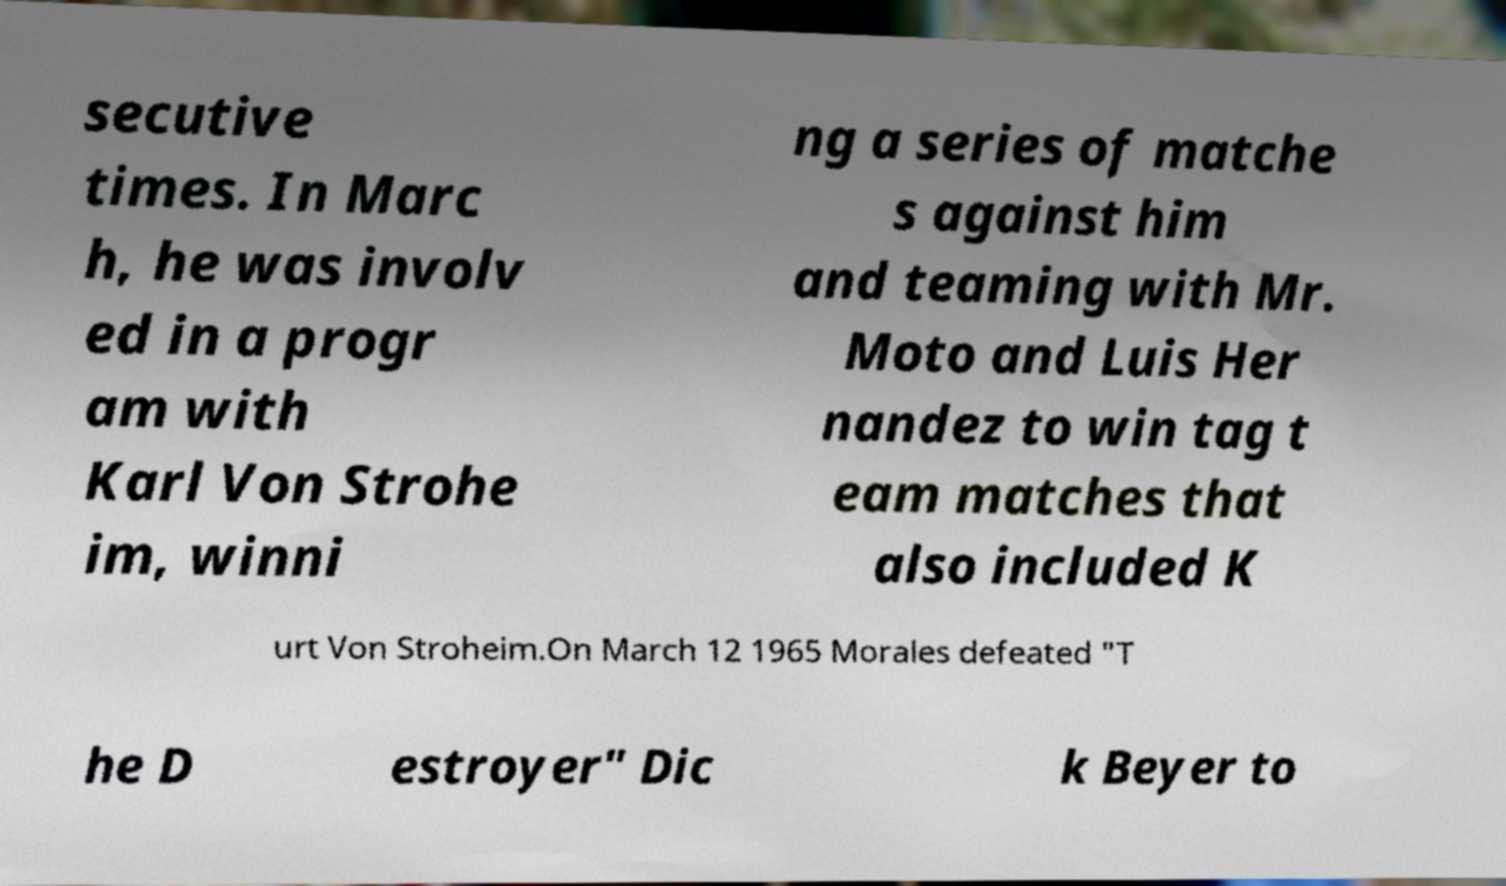Please identify and transcribe the text found in this image. secutive times. In Marc h, he was involv ed in a progr am with Karl Von Strohe im, winni ng a series of matche s against him and teaming with Mr. Moto and Luis Her nandez to win tag t eam matches that also included K urt Von Stroheim.On March 12 1965 Morales defeated "T he D estroyer" Dic k Beyer to 